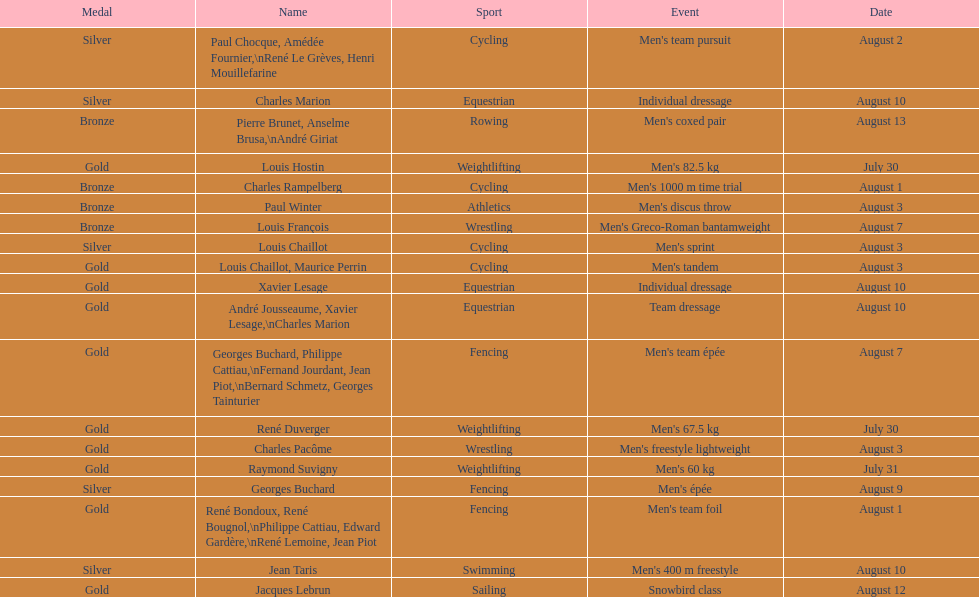What sport did louis challiot win the same medal as paul chocque in? Cycling. 